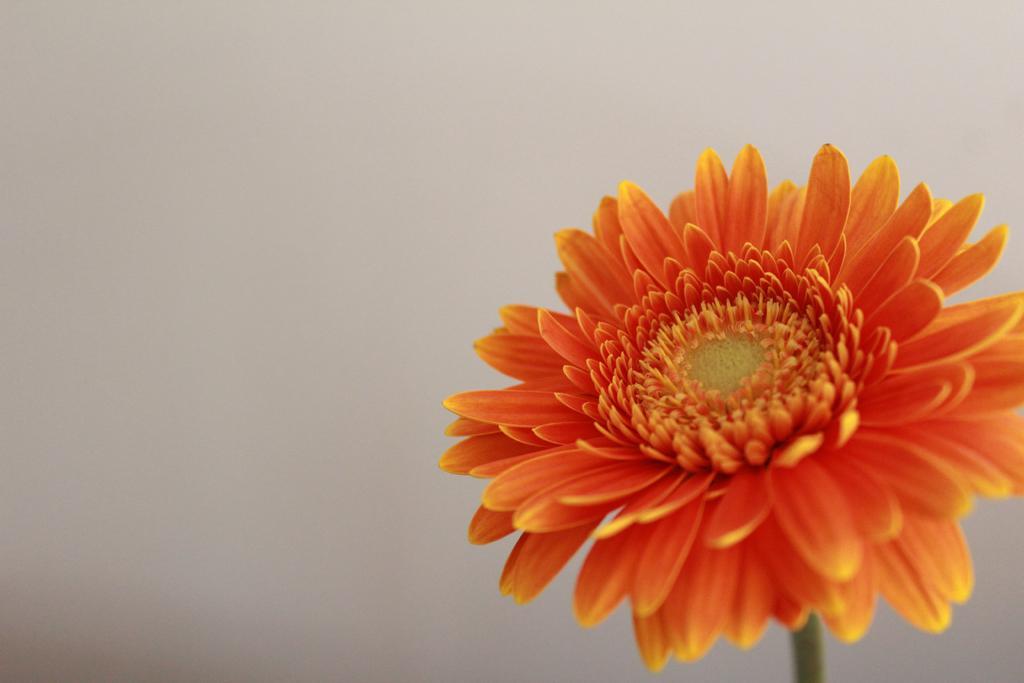How would you summarize this image in a sentence or two? In this picture we can see an orange color flower and in the background it is white color. 